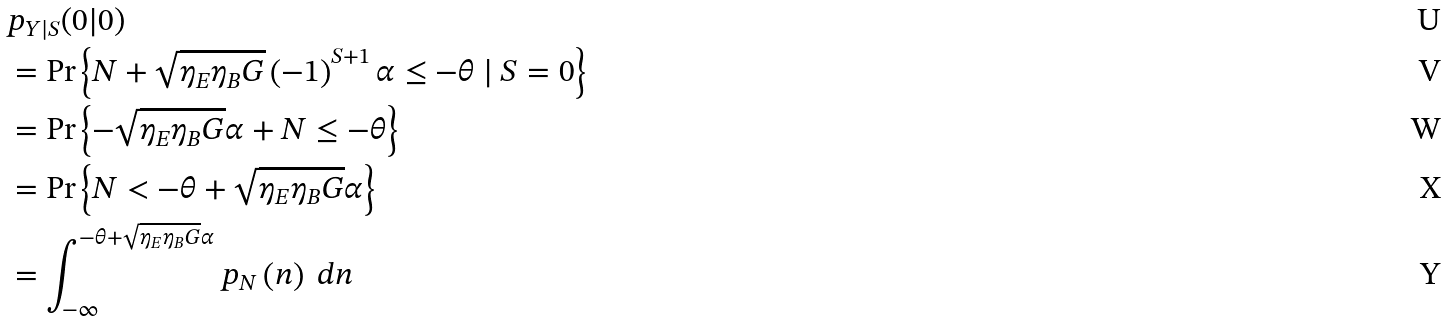<formula> <loc_0><loc_0><loc_500><loc_500>& p _ { Y | S } ( 0 | 0 ) \\ & = \Pr \left \{ N + \sqrt { \eta _ { E } \eta _ { B } G } \left ( - 1 \right ) ^ { S + 1 } \alpha \leq - \theta \ | \ S = 0 \right \} \\ & = \Pr \left \{ - \sqrt { \eta _ { E } \eta _ { B } G } \alpha + N \leq - \theta \right \} \\ & = \Pr \left \{ N < - \theta + \sqrt { \eta _ { E } \eta _ { B } G } \alpha \right \} \\ & = \int _ { - \infty } ^ { - \theta + \sqrt { \eta _ { E } \eta _ { B } G } \alpha } p _ { N } \left ( n \right ) \ d n</formula> 